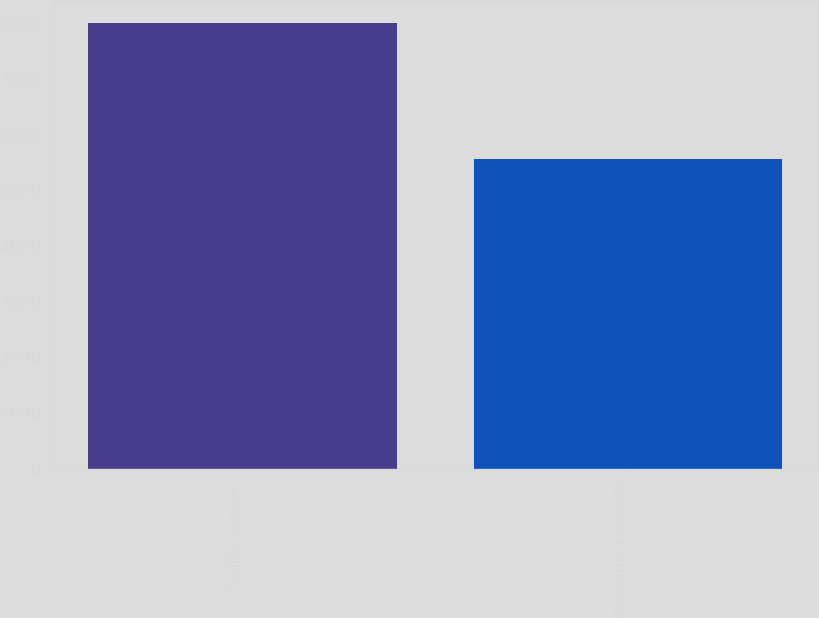<chart> <loc_0><loc_0><loc_500><loc_500><bar_chart><fcel>Facility size (a)<fcel>Available capacity<nl><fcel>8000<fcel>5557<nl></chart> 